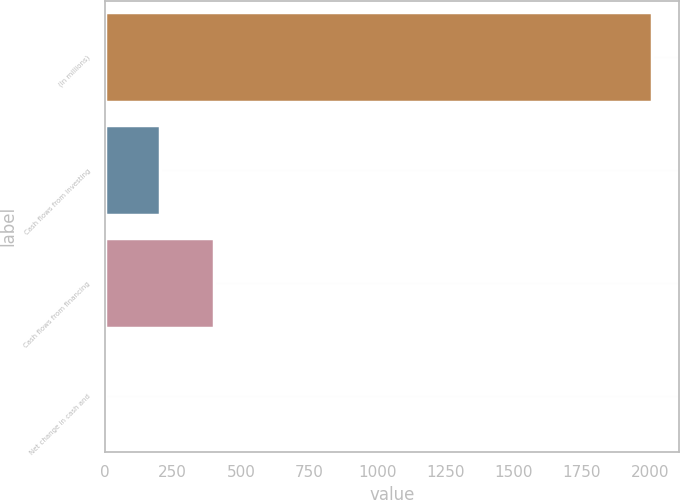Convert chart to OTSL. <chart><loc_0><loc_0><loc_500><loc_500><bar_chart><fcel>(In millions)<fcel>Cash flows from investing<fcel>Cash flows from financing<fcel>Net change in cash and<nl><fcel>2006<fcel>201.5<fcel>402<fcel>1<nl></chart> 